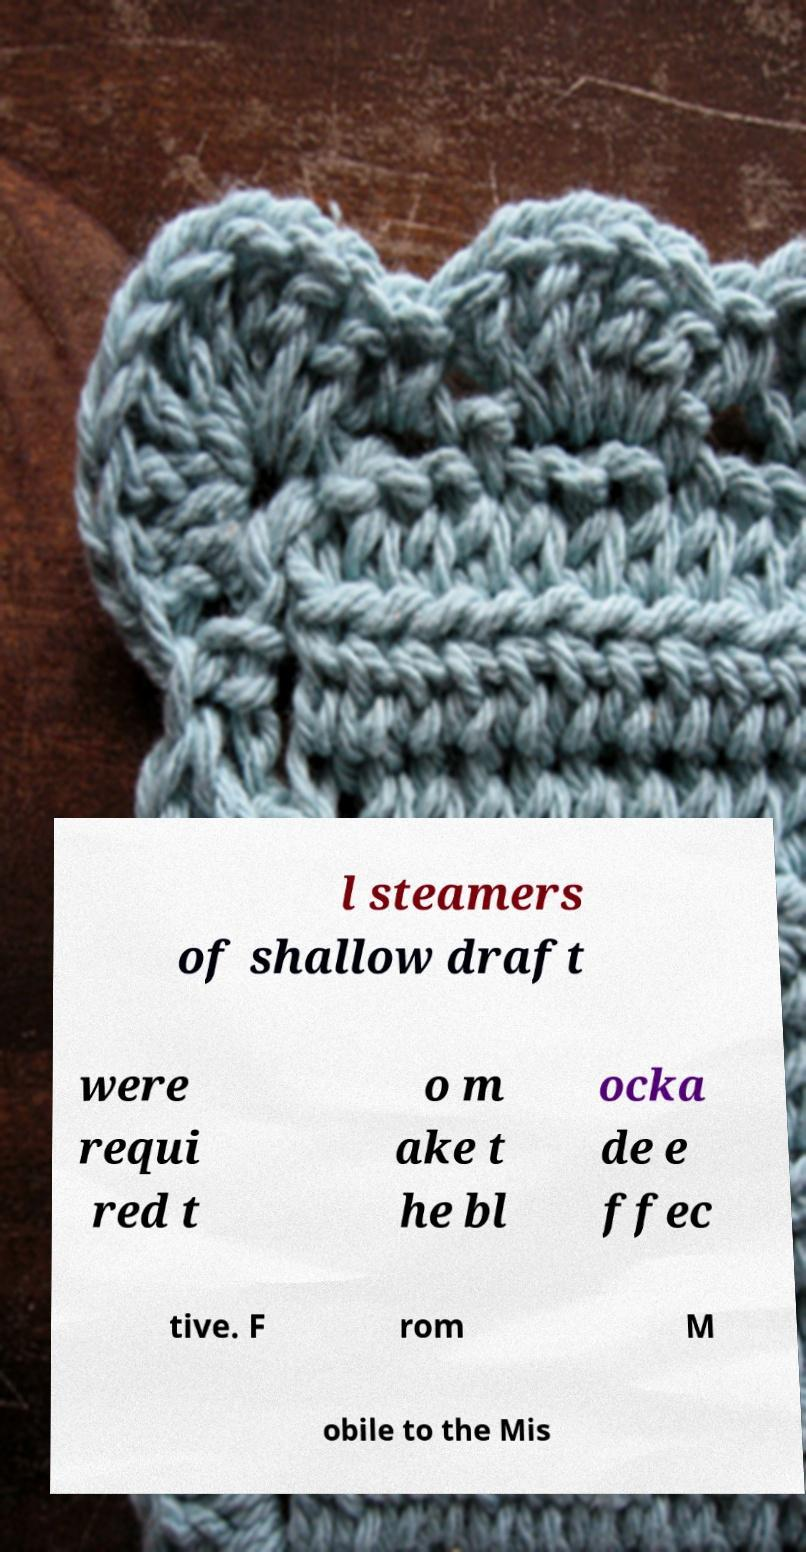Please identify and transcribe the text found in this image. l steamers of shallow draft were requi red t o m ake t he bl ocka de e ffec tive. F rom M obile to the Mis 